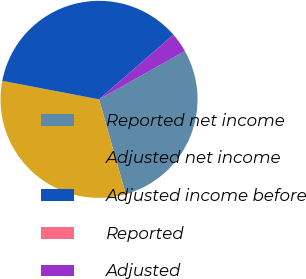Convert chart to OTSL. <chart><loc_0><loc_0><loc_500><loc_500><pie_chart><fcel>Reported net income<fcel>Adjusted net income<fcel>Adjusted income before<fcel>Reported<fcel>Adjusted<nl><fcel>28.78%<fcel>32.37%<fcel>35.61%<fcel>0.0%<fcel>3.24%<nl></chart> 